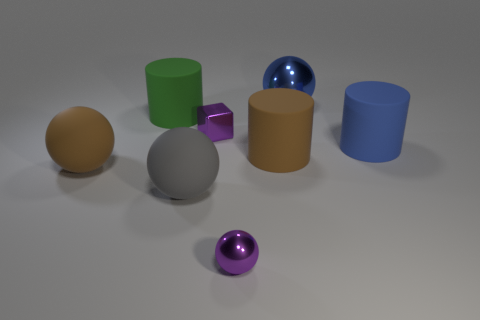What is the color of the large ball that is the same material as the small cube?
Make the answer very short. Blue. What number of large matte balls are left of the tiny ball?
Make the answer very short. 2. Is the color of the tiny metal thing that is in front of the brown cylinder the same as the tiny thing that is behind the gray rubber thing?
Ensure brevity in your answer.  Yes. What color is the other metallic thing that is the same shape as the big shiny object?
Offer a very short reply. Purple. Does the matte object that is left of the green matte cylinder have the same shape as the big blue object on the right side of the big shiny sphere?
Ensure brevity in your answer.  No. There is a purple block; is its size the same as the cylinder that is right of the blue ball?
Your answer should be compact. No. Are there more green rubber objects than matte spheres?
Make the answer very short. No. Do the large object to the left of the green cylinder and the green object that is behind the gray sphere have the same material?
Your answer should be very brief. Yes. What is the material of the large green cylinder?
Offer a terse response. Rubber. Are there more small blocks in front of the large brown sphere than tiny shiny things?
Your response must be concise. No. 